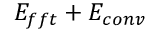Convert formula to latex. <formula><loc_0><loc_0><loc_500><loc_500>E _ { f f t } + E _ { c o n v }</formula> 